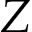Convert formula to latex. <formula><loc_0><loc_0><loc_500><loc_500>Z</formula> 